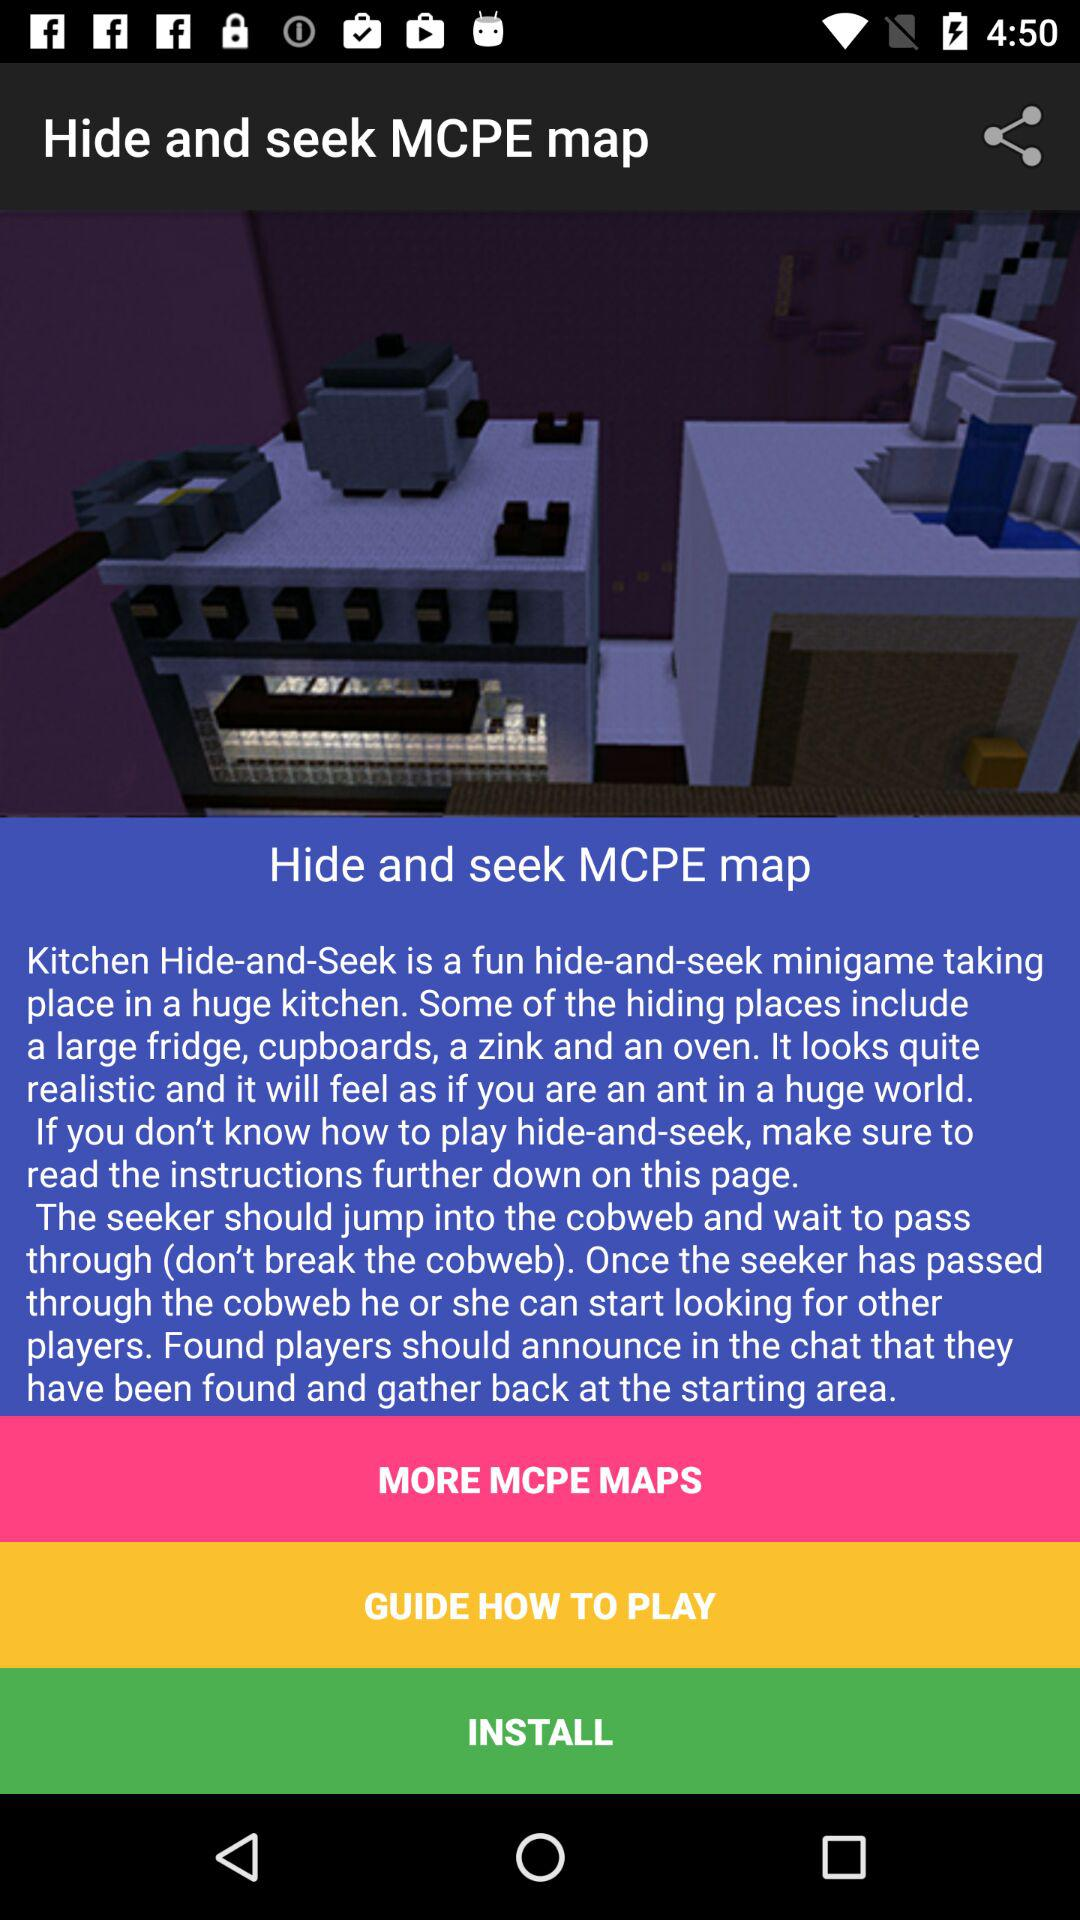What is the app name? The app name is "Hide and seek MCPE map". 